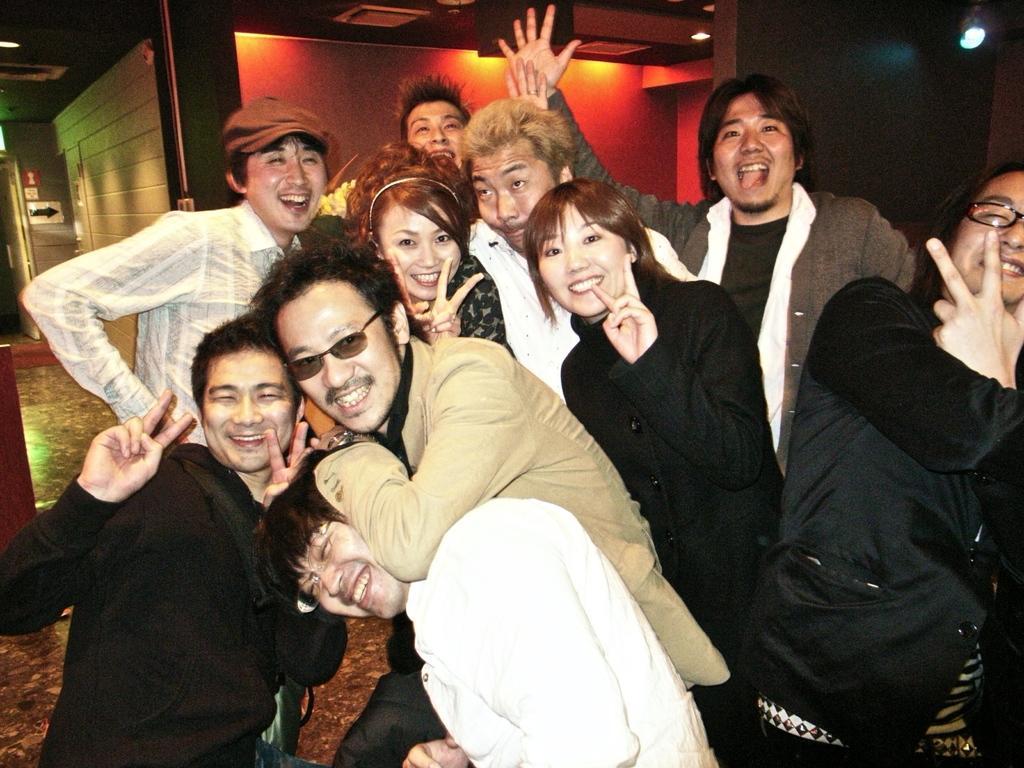Describe this image in one or two sentences. In this picture I can see there is a group of people standing and the person at the right is having spectacles, they are posing for the photograph. The person at the center is also having glasses and there are lights attached to the ceiling and there is a wall in the backdrop. 